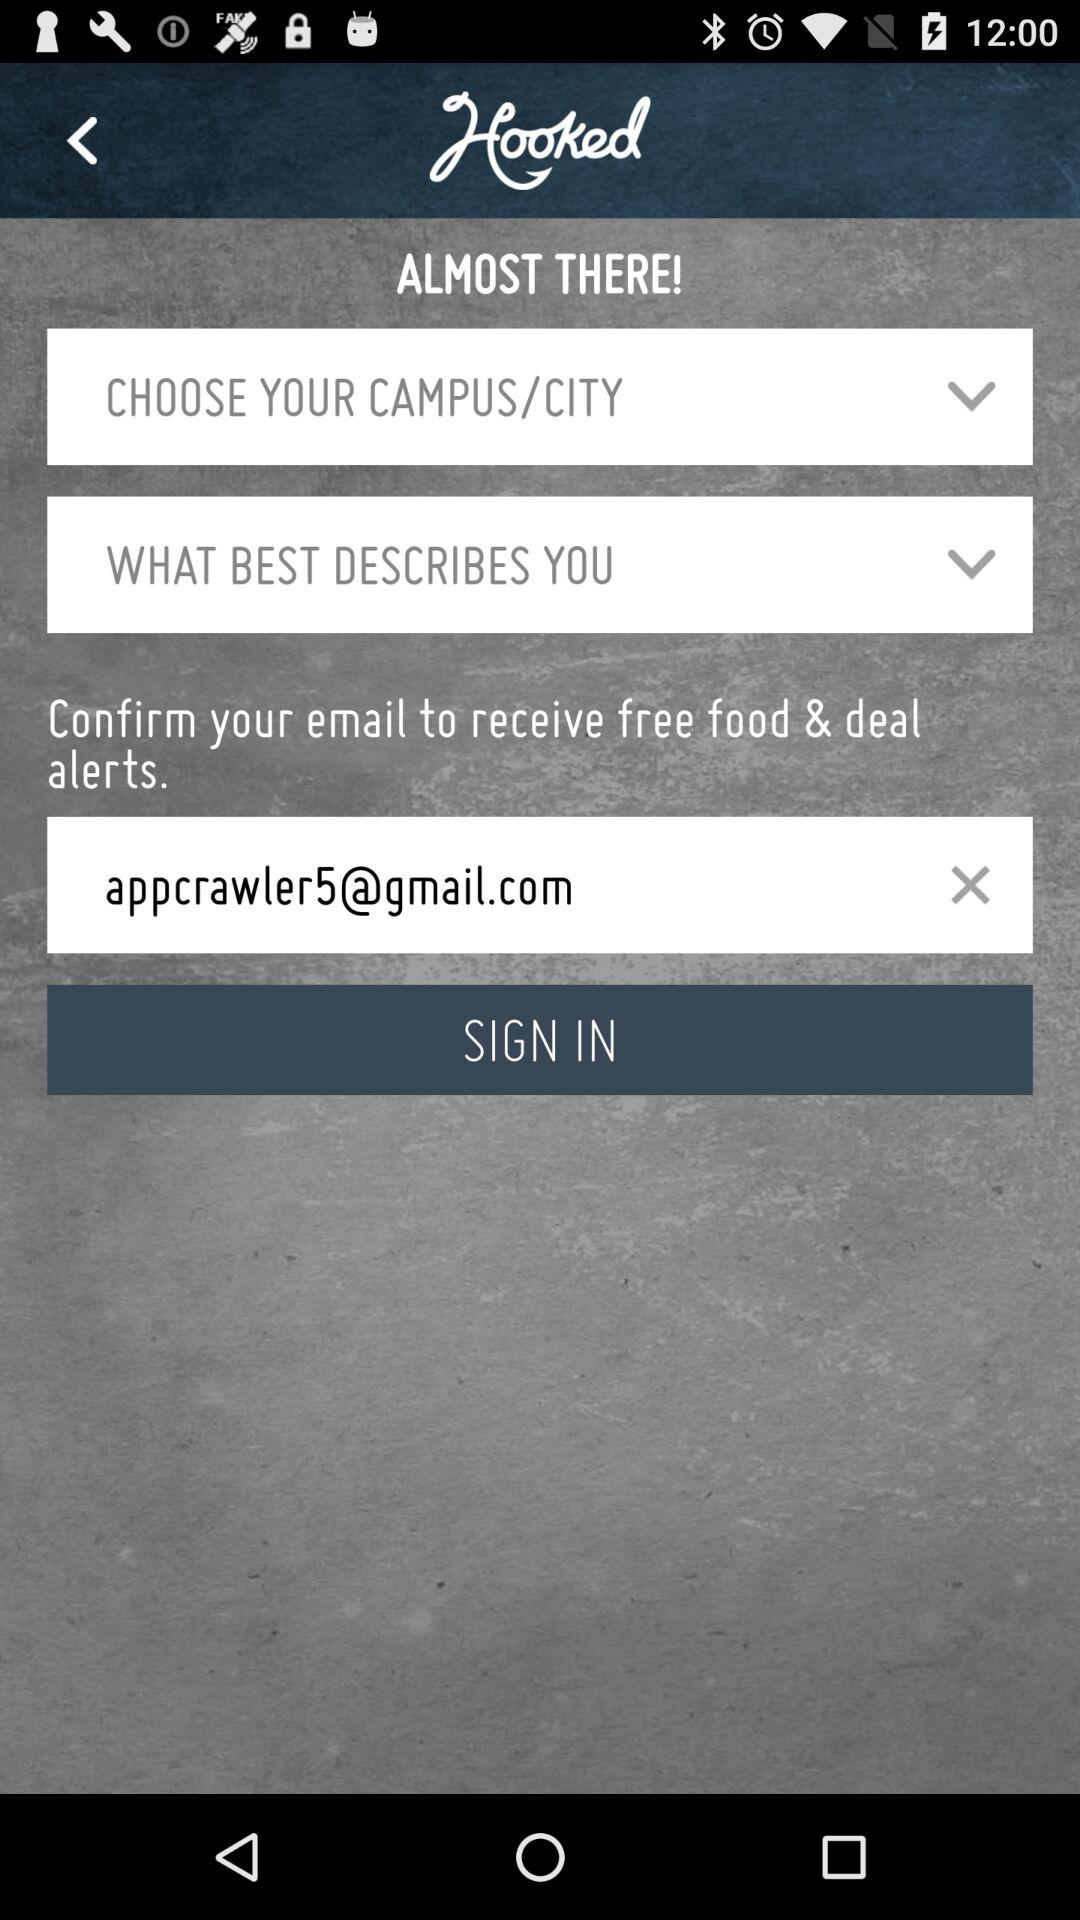What is the email address? The email address is appcrawler5@gmail.com. 